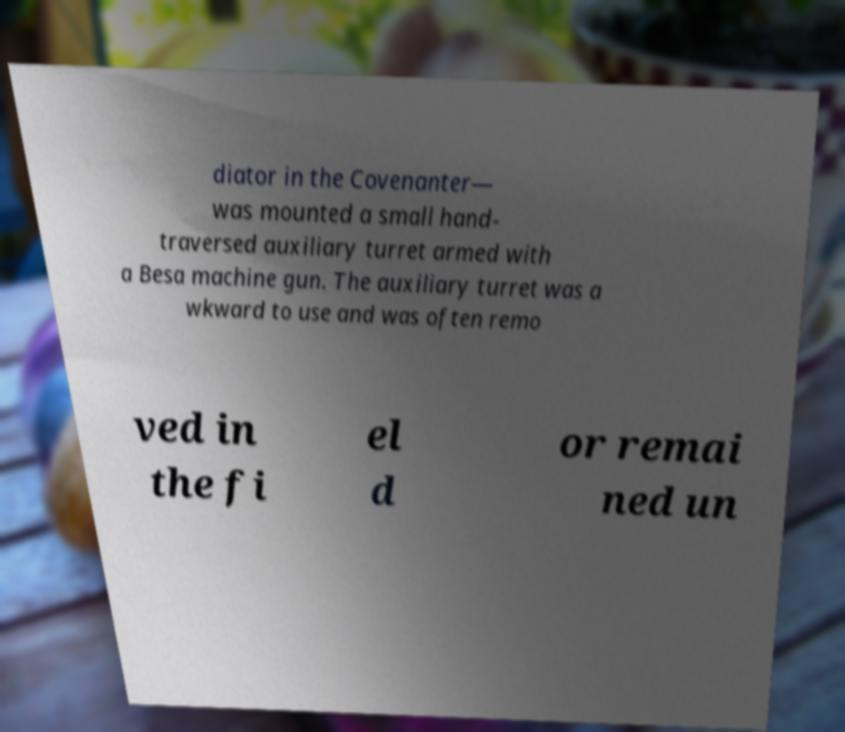For documentation purposes, I need the text within this image transcribed. Could you provide that? diator in the Covenanter— was mounted a small hand- traversed auxiliary turret armed with a Besa machine gun. The auxiliary turret was a wkward to use and was often remo ved in the fi el d or remai ned un 